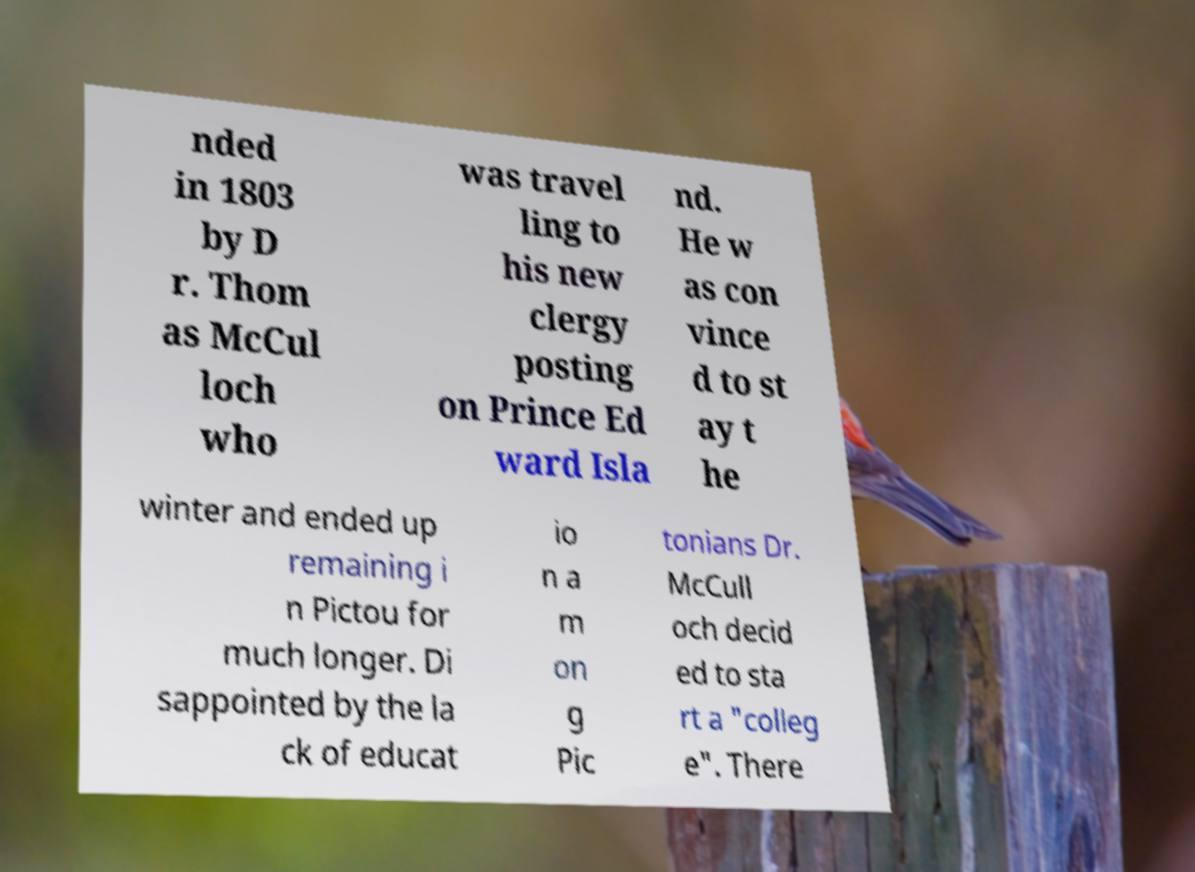Please read and relay the text visible in this image. What does it say? nded in 1803 by D r. Thom as McCul loch who was travel ling to his new clergy posting on Prince Ed ward Isla nd. He w as con vince d to st ay t he winter and ended up remaining i n Pictou for much longer. Di sappointed by the la ck of educat io n a m on g Pic tonians Dr. McCull och decid ed to sta rt a "colleg e". There 